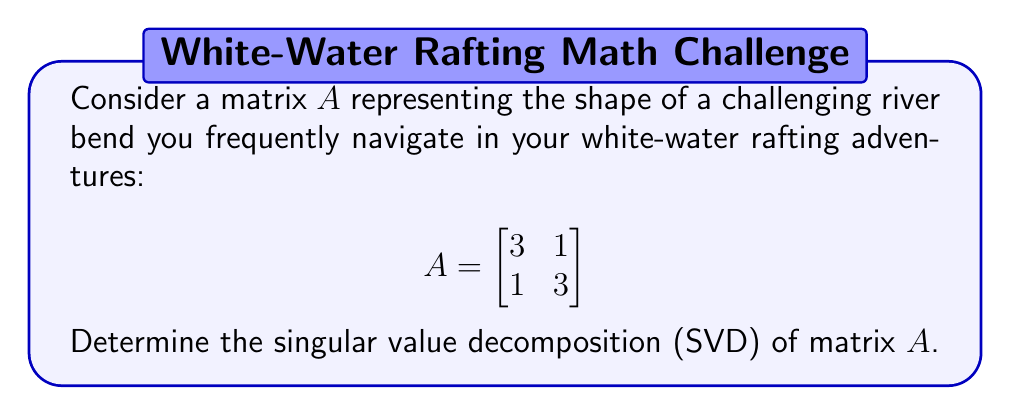Can you answer this question? To find the singular value decomposition of matrix $A$, we need to follow these steps:

1) First, calculate $A^TA$:
   $$A^TA = \begin{bmatrix}
   3 & 1 \\
   1 & 3
   \end{bmatrix}
   \begin{bmatrix}
   3 & 1 \\
   1 & 3
   \end{bmatrix}
   = \begin{bmatrix}
   10 & 6 \\
   6 & 10
   \end{bmatrix}$$

2) Find the eigenvalues of $A^TA$:
   $\det(A^TA - \lambda I) = \begin{vmatrix}
   10-\lambda & 6 \\
   6 & 10-\lambda
   \end{vmatrix} = (10-\lambda)^2 - 36 = \lambda^2 - 20\lambda + 64 = 0$
   
   Solving this equation: $\lambda_1 = 16$, $\lambda_2 = 4$

3) The singular values are the square roots of these eigenvalues:
   $\sigma_1 = \sqrt{16} = 4$, $\sigma_2 = \sqrt{4} = 2$

4) Find the right singular vectors (eigenvectors of $A^TA$):
   For $\lambda_1 = 16$: $(A^TA - 16I)v = 0$
   $$\begin{bmatrix}
   -6 & 6 \\
   6 & -6
   \end{bmatrix}v = 0$$
   This gives $v_1 = \frac{1}{\sqrt{2}}[1, 1]^T$
   
   For $\lambda_2 = 4$: $(A^TA - 4I)v = 0$
   $$\begin{bmatrix}
   6 & 6 \\
   6 & 6
   \end{bmatrix}v = 0$$
   This gives $v_2 = \frac{1}{\sqrt{2}}[-1, 1]^T$

5) Calculate the left singular vectors:
   $u_1 = \frac{1}{\sigma_1}Av_1 = \frac{1}{4}\begin{bmatrix}
   3 & 1 \\
   1 & 3
   \end{bmatrix}\frac{1}{\sqrt{2}}\begin{bmatrix}
   1 \\
   1
   \end{bmatrix} = \frac{1}{\sqrt{2}}[1, 1]^T$
   
   $u_2 = \frac{1}{\sigma_2}Av_2 = \frac{1}{2}\begin{bmatrix}
   3 & 1 \\
   1 & 3
   \end{bmatrix}\frac{1}{\sqrt{2}}\begin{bmatrix}
   -1 \\
   1
   \end{bmatrix} = \frac{1}{\sqrt{2}}[-1, 1]^T$

6) The SVD is $A = U\Sigma V^T$, where:
   $U = [u_1 \quad u_2] = \frac{1}{\sqrt{2}}\begin{bmatrix}
   1 & -1 \\
   1 & 1
   \end{bmatrix}$
   
   $\Sigma = \begin{bmatrix}
   4 & 0 \\
   0 & 2
   \end{bmatrix}$
   
   $V = [v_1 \quad v_2] = \frac{1}{\sqrt{2}}\begin{bmatrix}
   1 & -1 \\
   1 & 1
   \end{bmatrix}$
Answer: $A = \frac{1}{\sqrt{2}}\begin{bmatrix}
1 & -1 \\
1 & 1
\end{bmatrix}
\begin{bmatrix}
4 & 0 \\
0 & 2
\end{bmatrix}
\frac{1}{\sqrt{2}}\begin{bmatrix}
1 & 1 \\
-1 & 1
\end{bmatrix}$ 